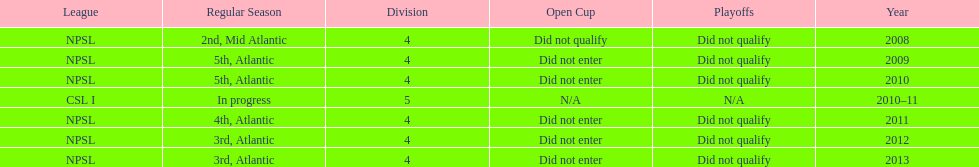How many 3rd place finishes has npsl had? 2. 